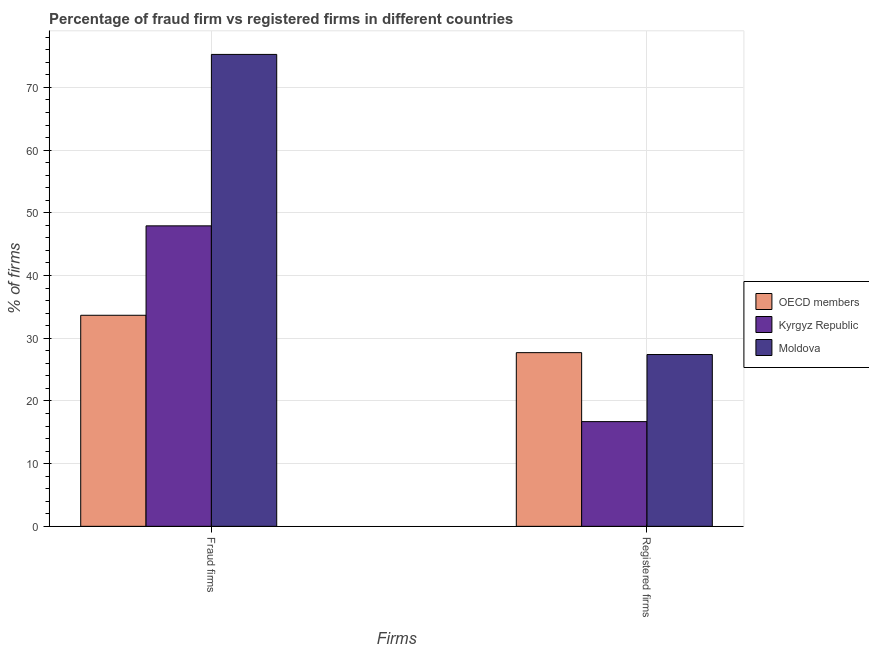How many bars are there on the 1st tick from the left?
Offer a terse response. 3. How many bars are there on the 1st tick from the right?
Ensure brevity in your answer.  3. What is the label of the 1st group of bars from the left?
Ensure brevity in your answer.  Fraud firms. What is the percentage of fraud firms in Moldova?
Provide a short and direct response. 75.26. Across all countries, what is the maximum percentage of registered firms?
Offer a very short reply. 27.7. Across all countries, what is the minimum percentage of registered firms?
Give a very brief answer. 16.7. In which country was the percentage of fraud firms maximum?
Provide a short and direct response. Moldova. In which country was the percentage of registered firms minimum?
Keep it short and to the point. Kyrgyz Republic. What is the total percentage of fraud firms in the graph?
Offer a terse response. 156.84. What is the difference between the percentage of registered firms in Kyrgyz Republic and the percentage of fraud firms in Moldova?
Ensure brevity in your answer.  -58.56. What is the average percentage of fraud firms per country?
Your answer should be compact. 52.28. What is the difference between the percentage of fraud firms and percentage of registered firms in Moldova?
Provide a succinct answer. 47.86. What is the ratio of the percentage of registered firms in Kyrgyz Republic to that in Moldova?
Make the answer very short. 0.61. Is the percentage of fraud firms in Kyrgyz Republic less than that in OECD members?
Your answer should be very brief. No. In how many countries, is the percentage of fraud firms greater than the average percentage of fraud firms taken over all countries?
Offer a terse response. 1. What does the 3rd bar from the left in Fraud firms represents?
Provide a short and direct response. Moldova. How many bars are there?
Your answer should be very brief. 6. Are all the bars in the graph horizontal?
Provide a succinct answer. No. What is the difference between two consecutive major ticks on the Y-axis?
Make the answer very short. 10. Does the graph contain any zero values?
Your answer should be compact. No. Does the graph contain grids?
Offer a very short reply. Yes. How many legend labels are there?
Your answer should be very brief. 3. How are the legend labels stacked?
Keep it short and to the point. Vertical. What is the title of the graph?
Keep it short and to the point. Percentage of fraud firm vs registered firms in different countries. What is the label or title of the X-axis?
Give a very brief answer. Firms. What is the label or title of the Y-axis?
Offer a very short reply. % of firms. What is the % of firms in OECD members in Fraud firms?
Your answer should be very brief. 33.66. What is the % of firms in Kyrgyz Republic in Fraud firms?
Ensure brevity in your answer.  47.92. What is the % of firms of Moldova in Fraud firms?
Make the answer very short. 75.26. What is the % of firms in OECD members in Registered firms?
Make the answer very short. 27.7. What is the % of firms in Moldova in Registered firms?
Your answer should be compact. 27.4. Across all Firms, what is the maximum % of firms of OECD members?
Provide a succinct answer. 33.66. Across all Firms, what is the maximum % of firms of Kyrgyz Republic?
Your response must be concise. 47.92. Across all Firms, what is the maximum % of firms of Moldova?
Give a very brief answer. 75.26. Across all Firms, what is the minimum % of firms of OECD members?
Your response must be concise. 27.7. Across all Firms, what is the minimum % of firms of Kyrgyz Republic?
Offer a very short reply. 16.7. Across all Firms, what is the minimum % of firms of Moldova?
Your answer should be compact. 27.4. What is the total % of firms in OECD members in the graph?
Provide a succinct answer. 61.36. What is the total % of firms in Kyrgyz Republic in the graph?
Your answer should be very brief. 64.62. What is the total % of firms in Moldova in the graph?
Offer a very short reply. 102.66. What is the difference between the % of firms of OECD members in Fraud firms and that in Registered firms?
Your answer should be compact. 5.96. What is the difference between the % of firms in Kyrgyz Republic in Fraud firms and that in Registered firms?
Ensure brevity in your answer.  31.22. What is the difference between the % of firms of Moldova in Fraud firms and that in Registered firms?
Make the answer very short. 47.86. What is the difference between the % of firms of OECD members in Fraud firms and the % of firms of Kyrgyz Republic in Registered firms?
Ensure brevity in your answer.  16.96. What is the difference between the % of firms of OECD members in Fraud firms and the % of firms of Moldova in Registered firms?
Ensure brevity in your answer.  6.26. What is the difference between the % of firms in Kyrgyz Republic in Fraud firms and the % of firms in Moldova in Registered firms?
Keep it short and to the point. 20.52. What is the average % of firms in OECD members per Firms?
Your answer should be very brief. 30.68. What is the average % of firms of Kyrgyz Republic per Firms?
Make the answer very short. 32.31. What is the average % of firms of Moldova per Firms?
Your answer should be compact. 51.33. What is the difference between the % of firms in OECD members and % of firms in Kyrgyz Republic in Fraud firms?
Provide a succinct answer. -14.26. What is the difference between the % of firms in OECD members and % of firms in Moldova in Fraud firms?
Provide a succinct answer. -41.6. What is the difference between the % of firms in Kyrgyz Republic and % of firms in Moldova in Fraud firms?
Keep it short and to the point. -27.34. What is the difference between the % of firms of OECD members and % of firms of Moldova in Registered firms?
Offer a very short reply. 0.3. What is the ratio of the % of firms in OECD members in Fraud firms to that in Registered firms?
Your answer should be compact. 1.22. What is the ratio of the % of firms in Kyrgyz Republic in Fraud firms to that in Registered firms?
Provide a succinct answer. 2.87. What is the ratio of the % of firms in Moldova in Fraud firms to that in Registered firms?
Your response must be concise. 2.75. What is the difference between the highest and the second highest % of firms of OECD members?
Your answer should be very brief. 5.96. What is the difference between the highest and the second highest % of firms in Kyrgyz Republic?
Make the answer very short. 31.22. What is the difference between the highest and the second highest % of firms in Moldova?
Provide a succinct answer. 47.86. What is the difference between the highest and the lowest % of firms in OECD members?
Ensure brevity in your answer.  5.96. What is the difference between the highest and the lowest % of firms in Kyrgyz Republic?
Offer a terse response. 31.22. What is the difference between the highest and the lowest % of firms of Moldova?
Give a very brief answer. 47.86. 